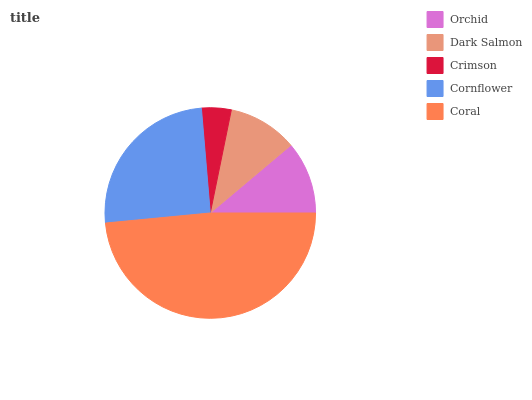Is Crimson the minimum?
Answer yes or no. Yes. Is Coral the maximum?
Answer yes or no. Yes. Is Dark Salmon the minimum?
Answer yes or no. No. Is Dark Salmon the maximum?
Answer yes or no. No. Is Orchid greater than Dark Salmon?
Answer yes or no. Yes. Is Dark Salmon less than Orchid?
Answer yes or no. Yes. Is Dark Salmon greater than Orchid?
Answer yes or no. No. Is Orchid less than Dark Salmon?
Answer yes or no. No. Is Orchid the high median?
Answer yes or no. Yes. Is Orchid the low median?
Answer yes or no. Yes. Is Cornflower the high median?
Answer yes or no. No. Is Coral the low median?
Answer yes or no. No. 